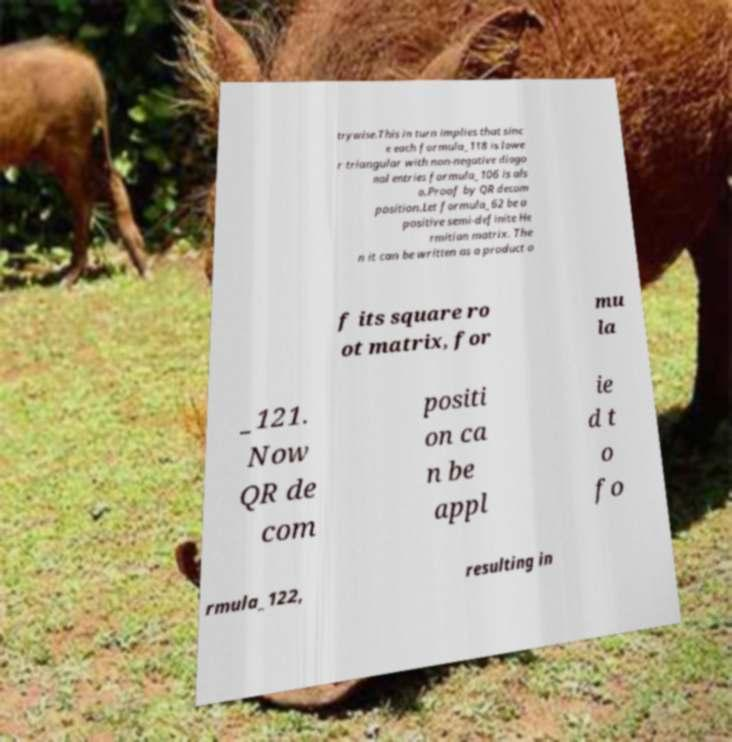There's text embedded in this image that I need extracted. Can you transcribe it verbatim? trywise.This in turn implies that sinc e each formula_118 is lowe r triangular with non-negative diago nal entries formula_106 is als o.Proof by QR decom position.Let formula_62 be a positive semi-definite He rmitian matrix. The n it can be written as a product o f its square ro ot matrix, for mu la _121. Now QR de com positi on ca n be appl ie d t o fo rmula_122, resulting in 